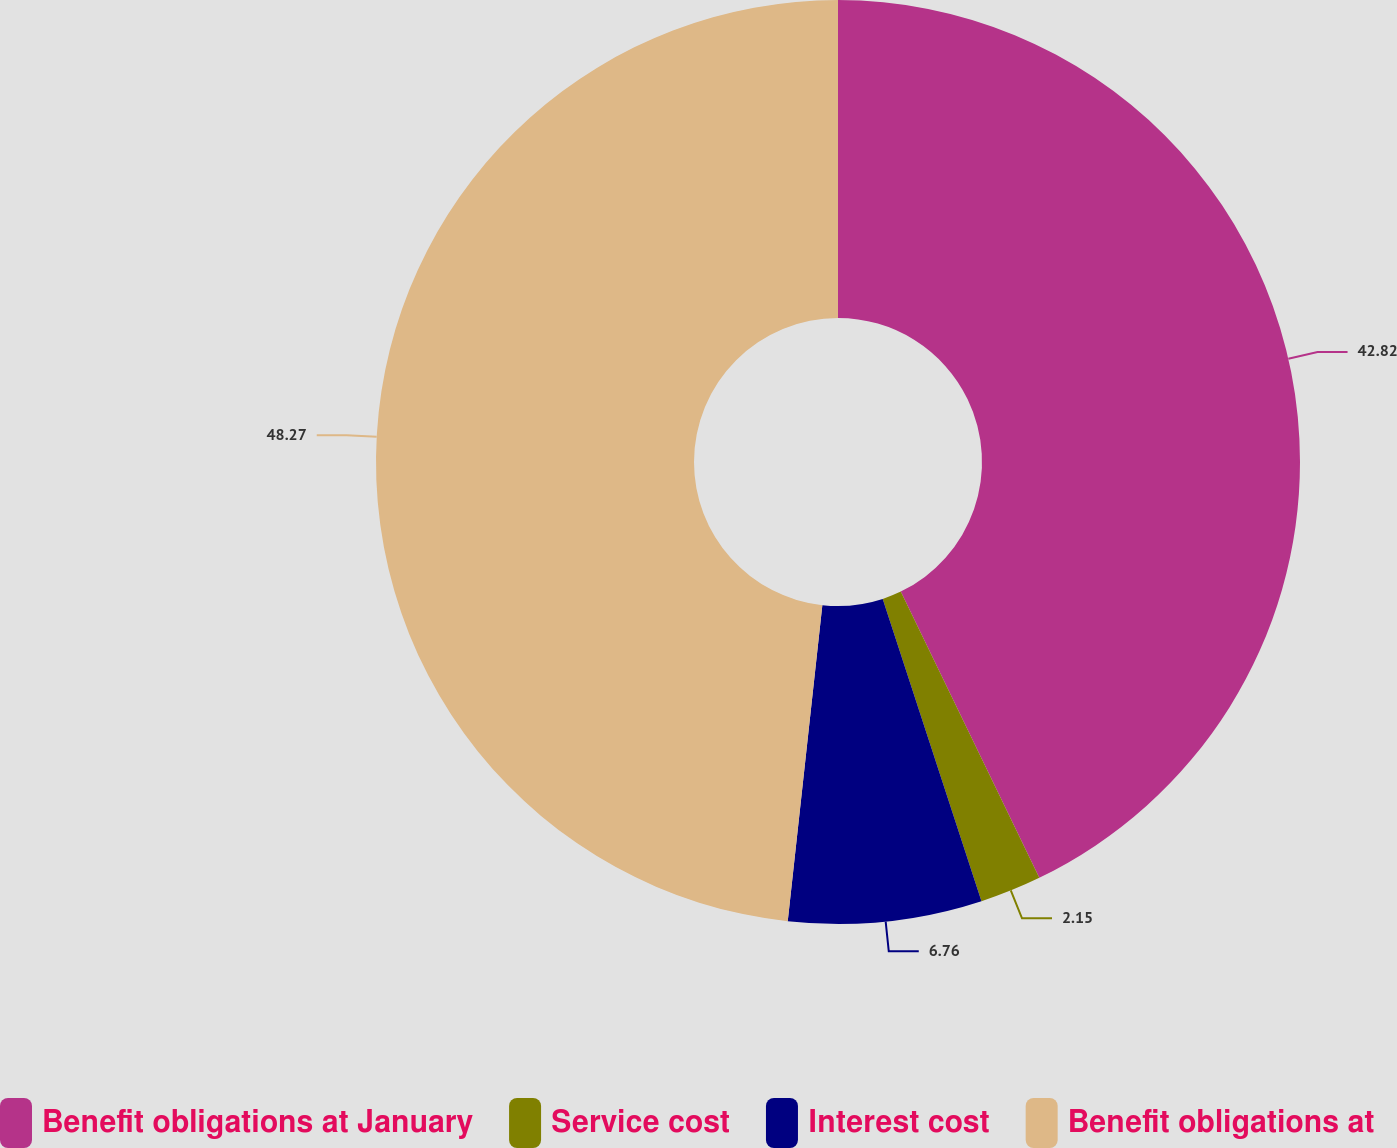Convert chart to OTSL. <chart><loc_0><loc_0><loc_500><loc_500><pie_chart><fcel>Benefit obligations at January<fcel>Service cost<fcel>Interest cost<fcel>Benefit obligations at<nl><fcel>42.82%<fcel>2.15%<fcel>6.76%<fcel>48.26%<nl></chart> 